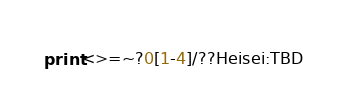Convert code to text. <code><loc_0><loc_0><loc_500><loc_500><_Perl_>print<>=~?0[1-4]/??Heisei:TBD</code> 